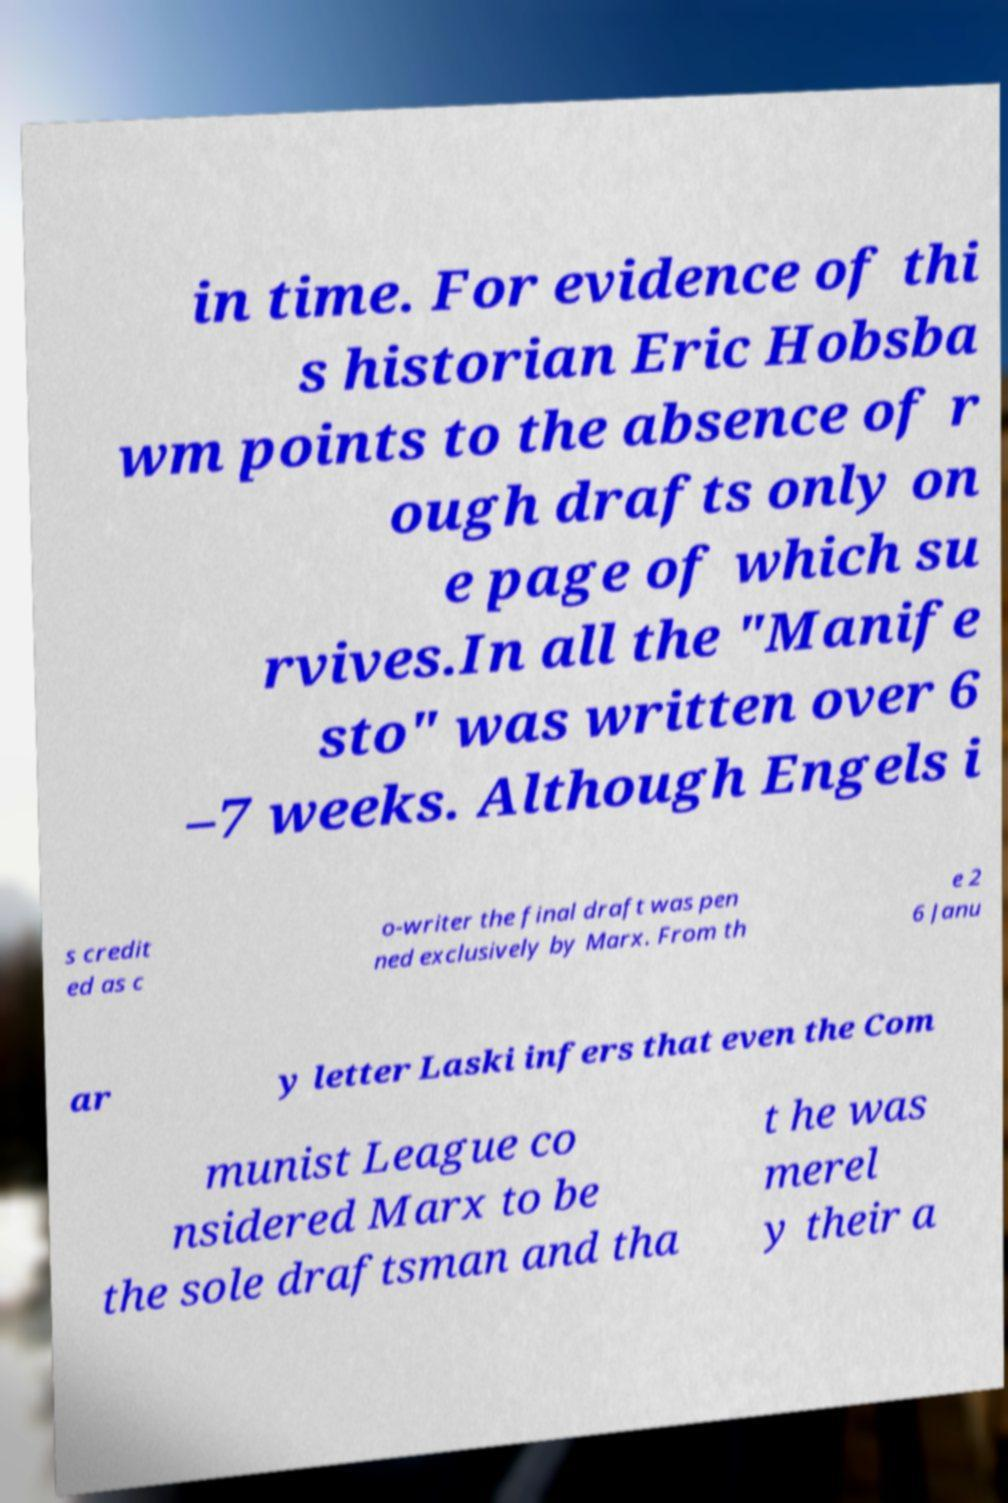Could you assist in decoding the text presented in this image and type it out clearly? in time. For evidence of thi s historian Eric Hobsba wm points to the absence of r ough drafts only on e page of which su rvives.In all the "Manife sto" was written over 6 –7 weeks. Although Engels i s credit ed as c o-writer the final draft was pen ned exclusively by Marx. From th e 2 6 Janu ar y letter Laski infers that even the Com munist League co nsidered Marx to be the sole draftsman and tha t he was merel y their a 